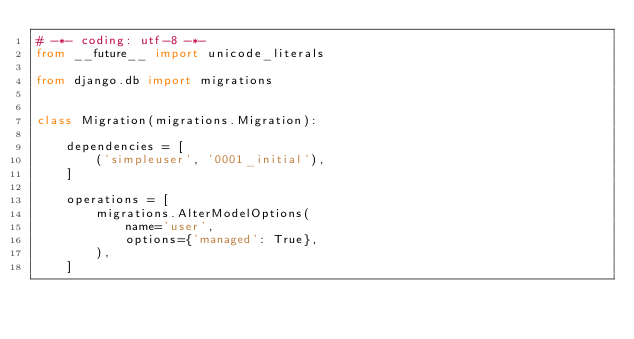<code> <loc_0><loc_0><loc_500><loc_500><_Python_># -*- coding: utf-8 -*-
from __future__ import unicode_literals

from django.db import migrations


class Migration(migrations.Migration):

    dependencies = [
        ('simpleuser', '0001_initial'),
    ]

    operations = [
        migrations.AlterModelOptions(
            name='user',
            options={'managed': True},
        ),
    ]
</code> 